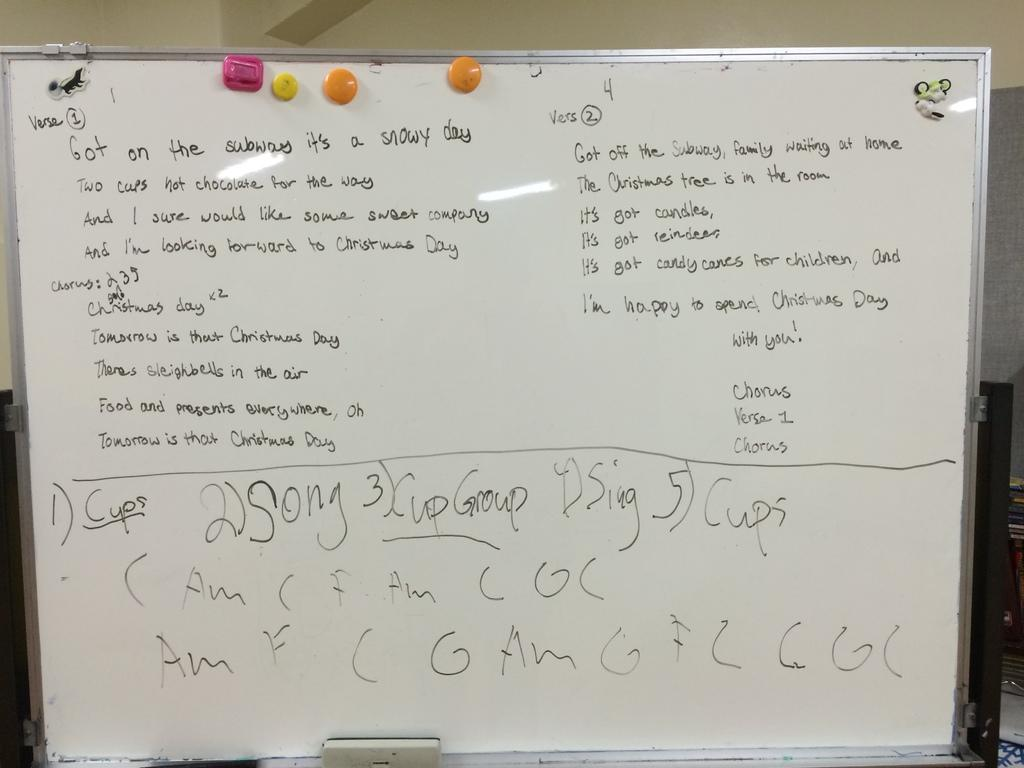Provide a one-sentence caption for the provided image. A whiteboard has the word "cups" underlined in black text. 